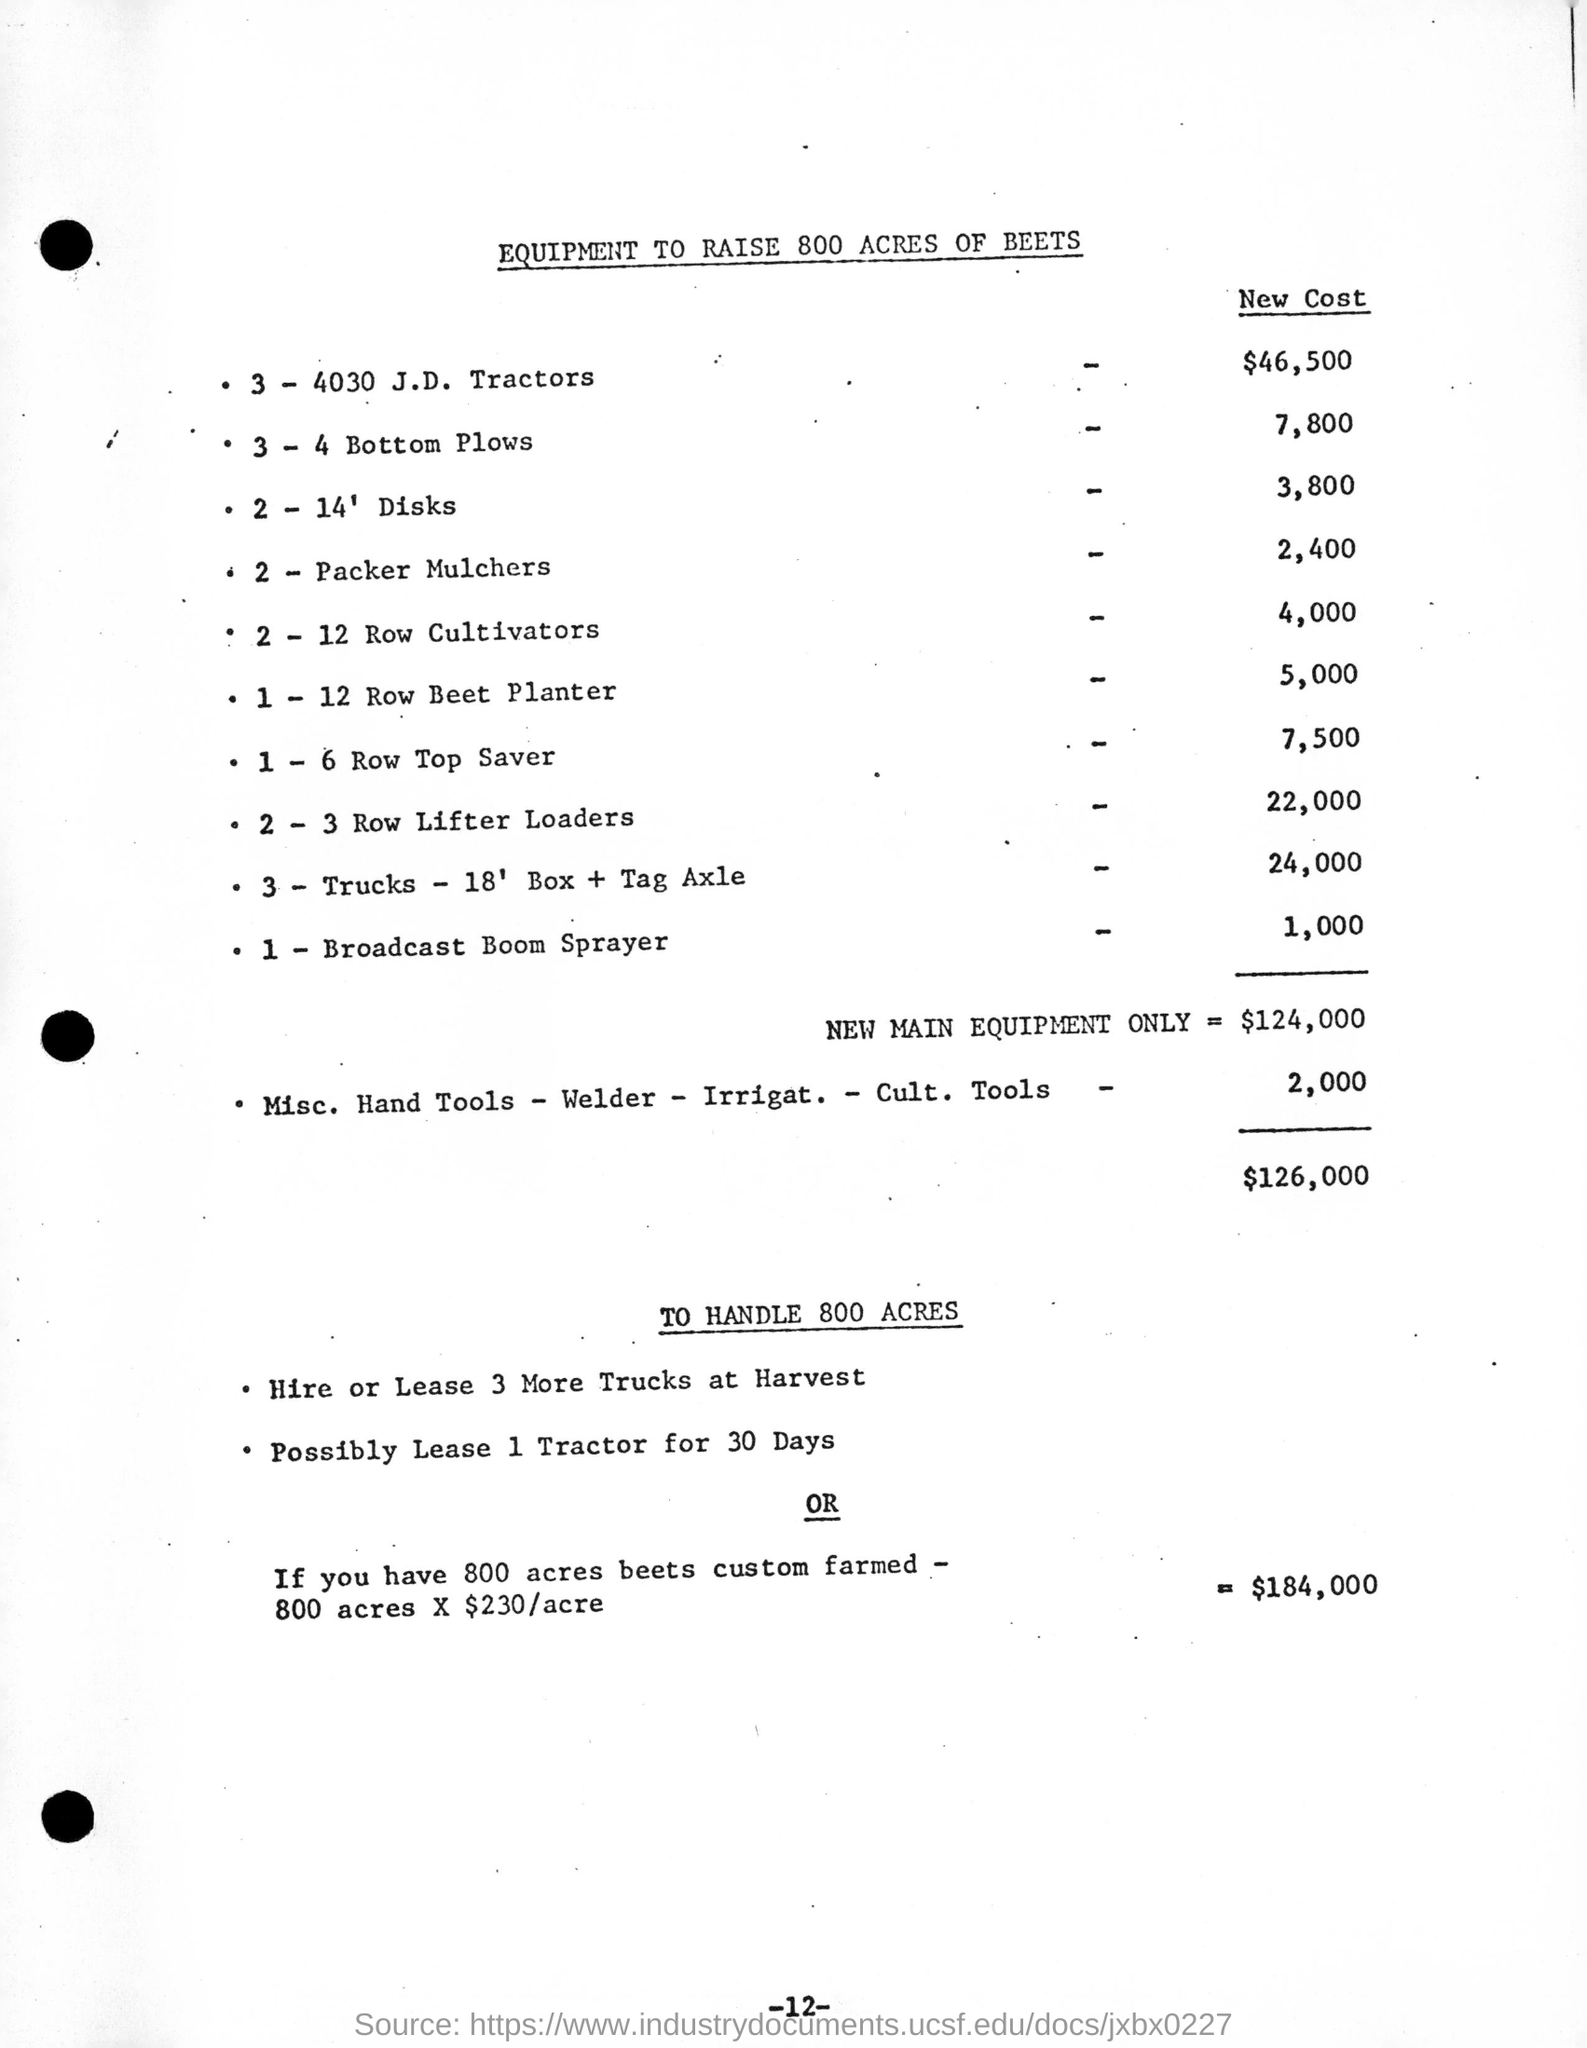What is the cost of new main equipment only ?
Ensure brevity in your answer.  $124,000. To handle 800 Acres how many more trucks need to be hired or taken for lease ?
Offer a very short reply. 3. Possibly 1 tractor can be taken to lease for how many days ?
Give a very brief answer. 30 DAYS. What is the new cost of 2 - packer mulchers
Keep it short and to the point. 2,400. What is the new cost for one broadcast boom sprayer?
Your answer should be very brief. 1000. What is the cost of one, 6 row top saver?
Ensure brevity in your answer.  7,500. In total how much would it cost for equipments for 800 acres?
Provide a short and direct response. $126,000. 